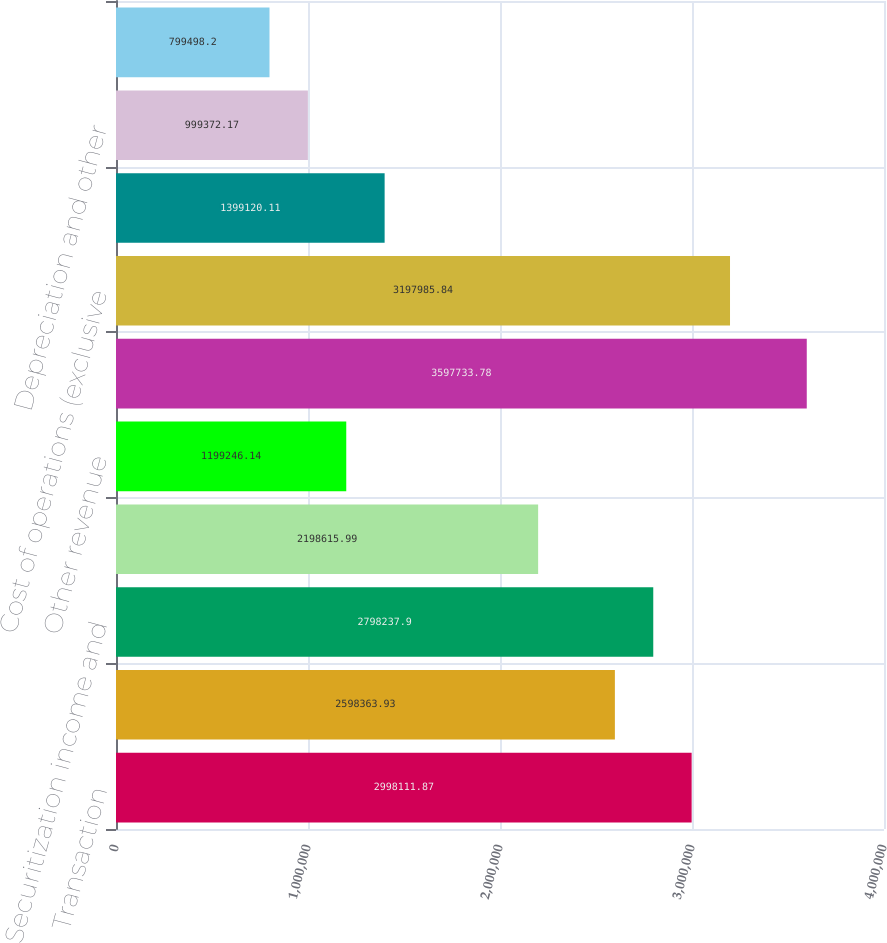Convert chart. <chart><loc_0><loc_0><loc_500><loc_500><bar_chart><fcel>Transaction<fcel>Redemption<fcel>Securitization income and<fcel>Database marketing fees and<fcel>Other revenue<fcel>Total revenue<fcel>Cost of operations (exclusive<fcel>General and administrative<fcel>Depreciation and other<fcel>Amortization of purchased<nl><fcel>2.99811e+06<fcel>2.59836e+06<fcel>2.79824e+06<fcel>2.19862e+06<fcel>1.19925e+06<fcel>3.59773e+06<fcel>3.19799e+06<fcel>1.39912e+06<fcel>999372<fcel>799498<nl></chart> 